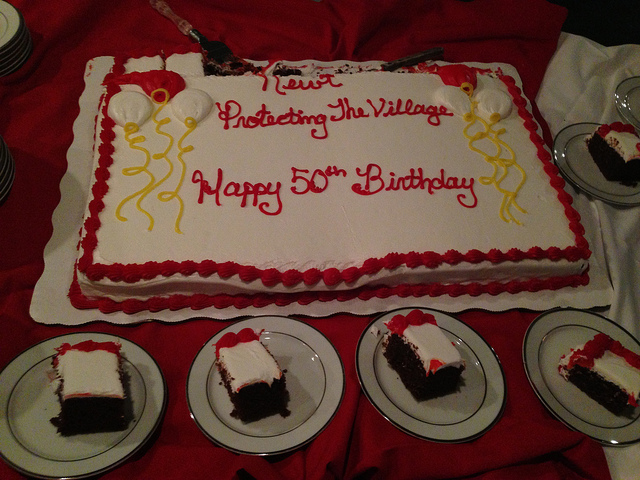Identify the text displayed in this image. Protecting Village The Happy 50th Birthday 